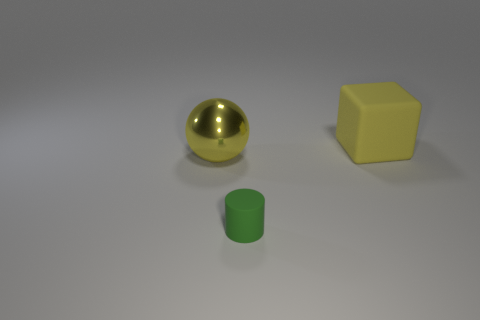Does the block have the same color as the shiny ball?
Keep it short and to the point. Yes. Is there any other thing that has the same size as the green thing?
Offer a terse response. No. Do the yellow matte object and the thing that is in front of the yellow shiny thing have the same size?
Your answer should be compact. No. What is the shape of the yellow object in front of the matte cube?
Give a very brief answer. Sphere. The rubber thing on the left side of the large yellow object that is to the right of the big sphere is what color?
Offer a terse response. Green. How many small cylinders have the same color as the small object?
Give a very brief answer. 0. Does the ball have the same color as the rubber thing on the right side of the green thing?
Make the answer very short. Yes. What is the shape of the thing that is both in front of the cube and on the right side of the big yellow ball?
Your answer should be very brief. Cylinder. There is a thing that is left of the matte thing that is in front of the yellow object that is right of the yellow shiny sphere; what is its material?
Provide a succinct answer. Metal. Are there more big metal things that are behind the big matte cube than matte blocks that are to the left of the large yellow metallic thing?
Ensure brevity in your answer.  No. 